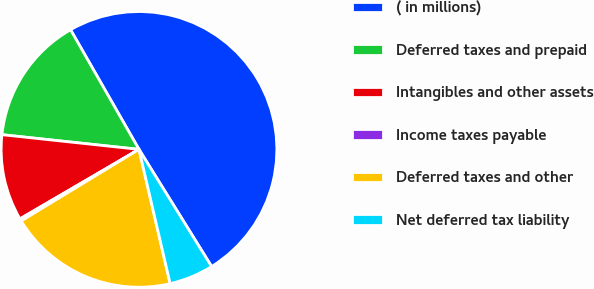Convert chart to OTSL. <chart><loc_0><loc_0><loc_500><loc_500><pie_chart><fcel>( in millions)<fcel>Deferred taxes and prepaid<fcel>Intangibles and other assets<fcel>Income taxes payable<fcel>Deferred taxes and other<fcel>Net deferred tax liability<nl><fcel>49.44%<fcel>15.03%<fcel>10.11%<fcel>0.28%<fcel>19.94%<fcel>5.2%<nl></chart> 